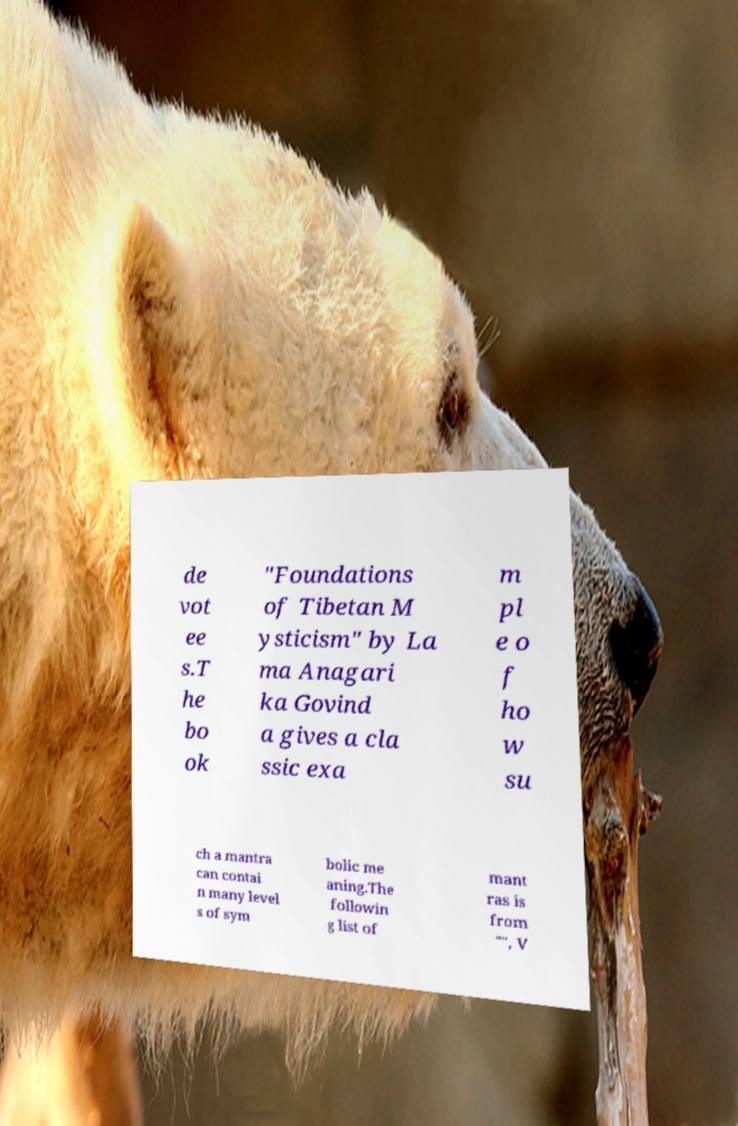For documentation purposes, I need the text within this image transcribed. Could you provide that? de vot ee s.T he bo ok "Foundations of Tibetan M ysticism" by La ma Anagari ka Govind a gives a cla ssic exa m pl e o f ho w su ch a mantra can contai n many level s of sym bolic me aning.The followin g list of mant ras is from "", V 